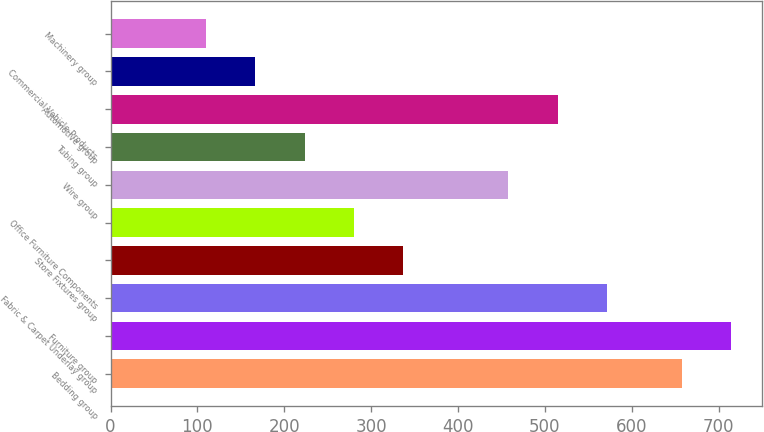<chart> <loc_0><loc_0><loc_500><loc_500><bar_chart><fcel>Bedding group<fcel>Furniture group<fcel>Fabric & Carpet Underlay group<fcel>Store Fixtures group<fcel>Office Furniture Components<fcel>Wire group<fcel>Tubing group<fcel>Automotive group<fcel>Commercial Vehicle Products<fcel>Machinery group<nl><fcel>657.6<fcel>714.3<fcel>571.3<fcel>336.7<fcel>280<fcel>457.9<fcel>223.3<fcel>514.6<fcel>166.6<fcel>109.9<nl></chart> 